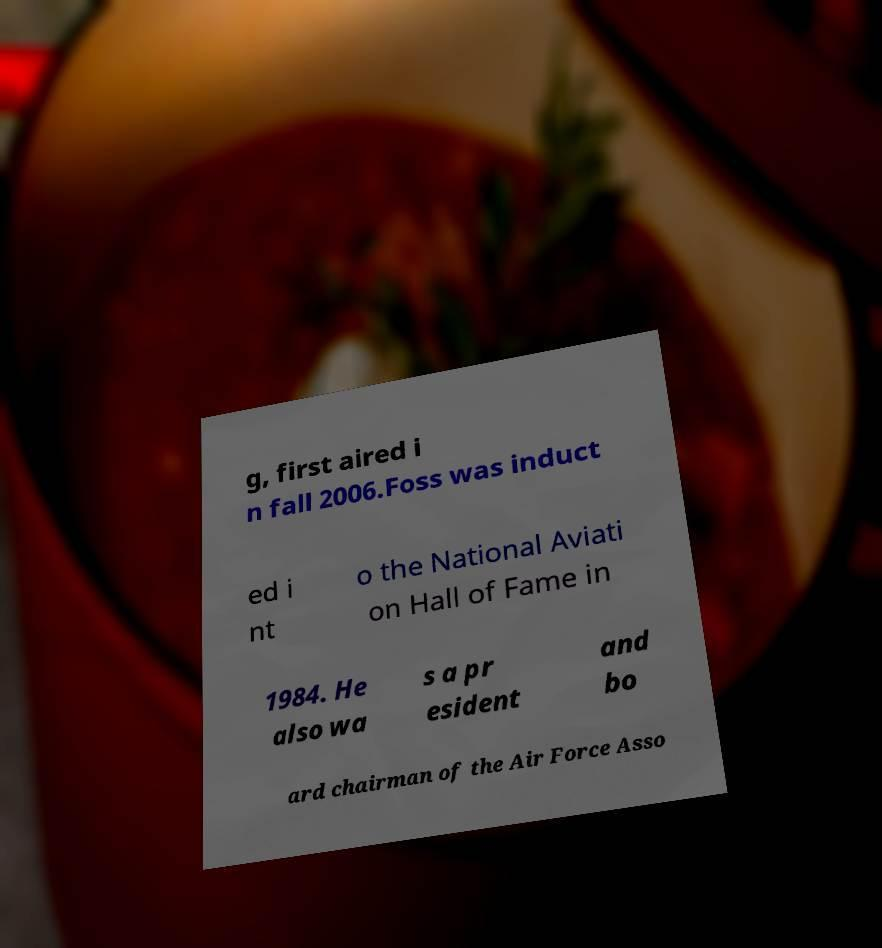There's text embedded in this image that I need extracted. Can you transcribe it verbatim? g, first aired i n fall 2006.Foss was induct ed i nt o the National Aviati on Hall of Fame in 1984. He also wa s a pr esident and bo ard chairman of the Air Force Asso 